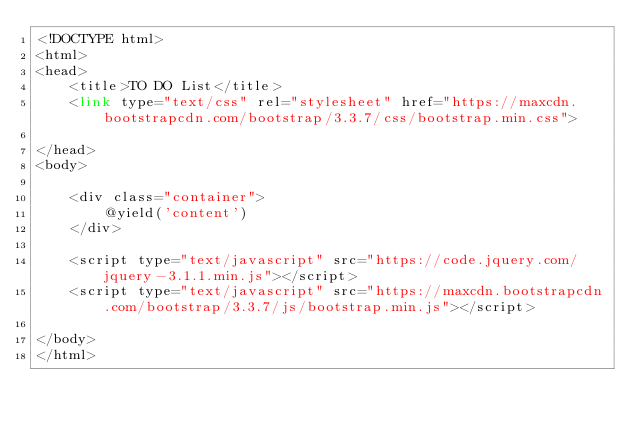Convert code to text. <code><loc_0><loc_0><loc_500><loc_500><_PHP_><!DOCTYPE html>
<html>
<head>
    <title>TO DO List</title>
    <link type="text/css" rel="stylesheet" href="https://maxcdn.bootstrapcdn.com/bootstrap/3.3.7/css/bootstrap.min.css">

</head>
<body>

    <div class="container">
        @yield('content')
    </div>
   
    <script type="text/javascript" src="https://code.jquery.com/jquery-3.1.1.min.js"></script>
    <script type="text/javascript" src="https://maxcdn.bootstrapcdn.com/bootstrap/3.3.7/js/bootstrap.min.js"></script>
    
</body>
</html></code> 